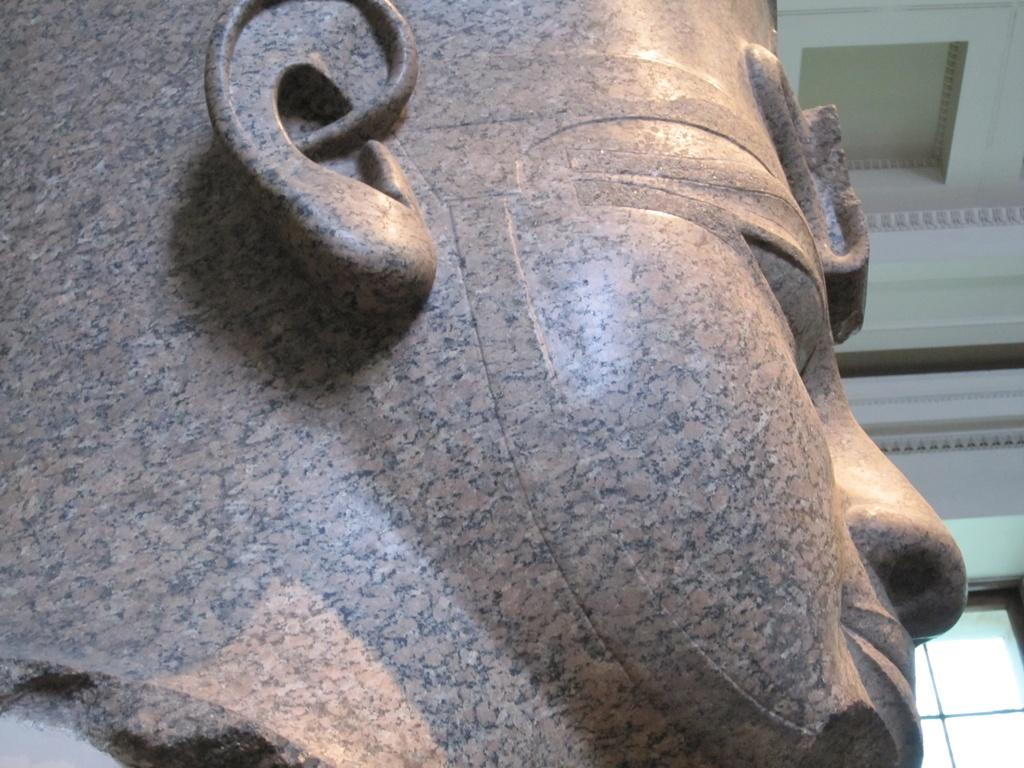What is the main subject of the image? There is a sculpture in the image. What can be seen above the sculpture? There is a ceiling visible in the image. What is present in the background of the image? There is a glass window in the background of the image. What type of toys can be seen on the mountain in the image? There is no mountain or toys present in the image; it features a sculpture and a ceiling. 